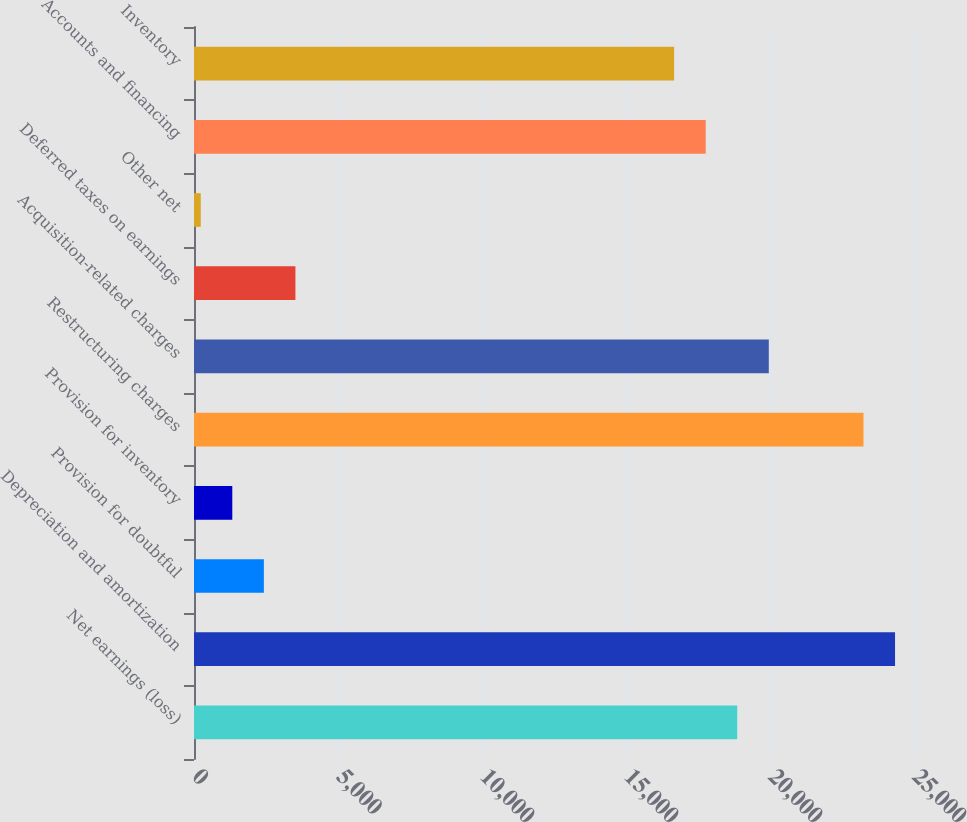<chart> <loc_0><loc_0><loc_500><loc_500><bar_chart><fcel>Net earnings (loss)<fcel>Depreciation and amortization<fcel>Provision for doubtful<fcel>Provision for inventory<fcel>Restructuring charges<fcel>Acquisition-related charges<fcel>Deferred taxes on earnings<fcel>Other net<fcel>Accounts and financing<fcel>Inventory<nl><fcel>18862.6<fcel>24341.6<fcel>2425.6<fcel>1329.8<fcel>23245.8<fcel>19958.4<fcel>3521.4<fcel>234<fcel>17766.8<fcel>16671<nl></chart> 